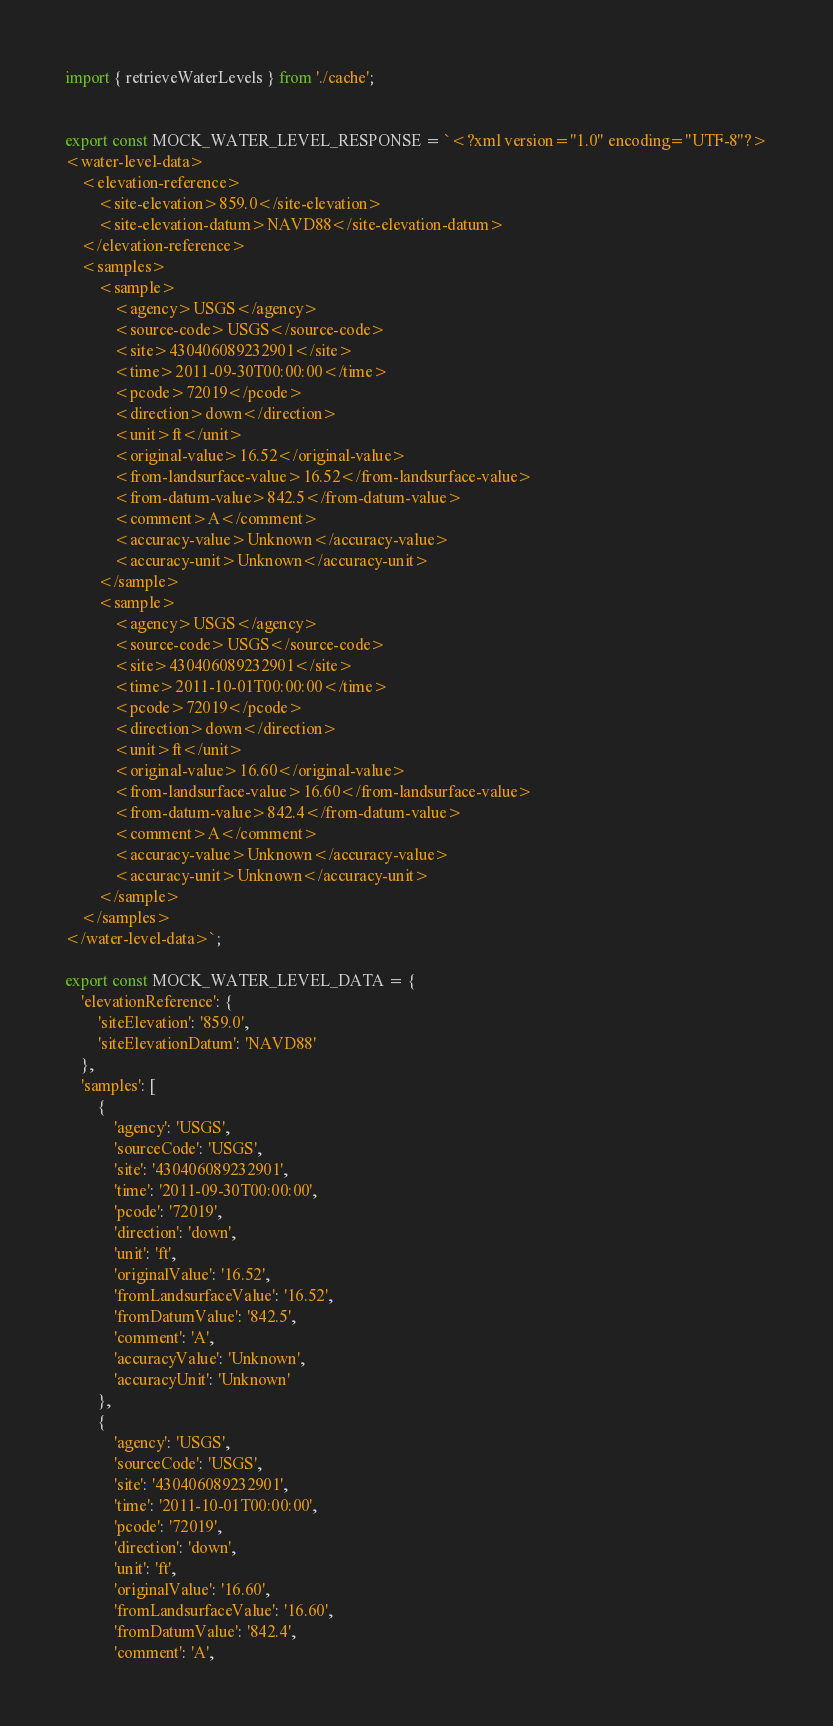Convert code to text. <code><loc_0><loc_0><loc_500><loc_500><_JavaScript_>import { retrieveWaterLevels } from './cache';


export const MOCK_WATER_LEVEL_RESPONSE = `<?xml version="1.0" encoding="UTF-8"?>
<water-level-data>
    <elevation-reference>
        <site-elevation>859.0</site-elevation>
        <site-elevation-datum>NAVD88</site-elevation-datum>
    </elevation-reference>
    <samples>
        <sample>
            <agency>USGS</agency>
            <source-code>USGS</source-code>
            <site>430406089232901</site>
            <time>2011-09-30T00:00:00</time>
            <pcode>72019</pcode>
            <direction>down</direction>
            <unit>ft</unit>
            <original-value>16.52</original-value>
            <from-landsurface-value>16.52</from-landsurface-value>
            <from-datum-value>842.5</from-datum-value>
            <comment>A</comment>
            <accuracy-value>Unknown</accuracy-value>
            <accuracy-unit>Unknown</accuracy-unit>
        </sample>
        <sample>
            <agency>USGS</agency>
            <source-code>USGS</source-code>
            <site>430406089232901</site>
            <time>2011-10-01T00:00:00</time>
            <pcode>72019</pcode>
            <direction>down</direction>
            <unit>ft</unit>
            <original-value>16.60</original-value>
            <from-landsurface-value>16.60</from-landsurface-value>
            <from-datum-value>842.4</from-datum-value>
            <comment>A</comment>
            <accuracy-value>Unknown</accuracy-value>
            <accuracy-unit>Unknown</accuracy-unit>
        </sample>
    </samples>
</water-level-data>`;

export const MOCK_WATER_LEVEL_DATA = {
    'elevationReference': {
        'siteElevation': '859.0',
        'siteElevationDatum': 'NAVD88'
    },
    'samples': [
        {
            'agency': 'USGS',
            'sourceCode': 'USGS',
            'site': '430406089232901',
            'time': '2011-09-30T00:00:00',
            'pcode': '72019',
            'direction': 'down',
            'unit': 'ft',
            'originalValue': '16.52',
            'fromLandsurfaceValue': '16.52',
            'fromDatumValue': '842.5',
            'comment': 'A',
            'accuracyValue': 'Unknown',
            'accuracyUnit': 'Unknown'
        },
        {
            'agency': 'USGS',
            'sourceCode': 'USGS',
            'site': '430406089232901',
            'time': '2011-10-01T00:00:00',
            'pcode': '72019',
            'direction': 'down',
            'unit': 'ft',
            'originalValue': '16.60',
            'fromLandsurfaceValue': '16.60',
            'fromDatumValue': '842.4',
            'comment': 'A',</code> 